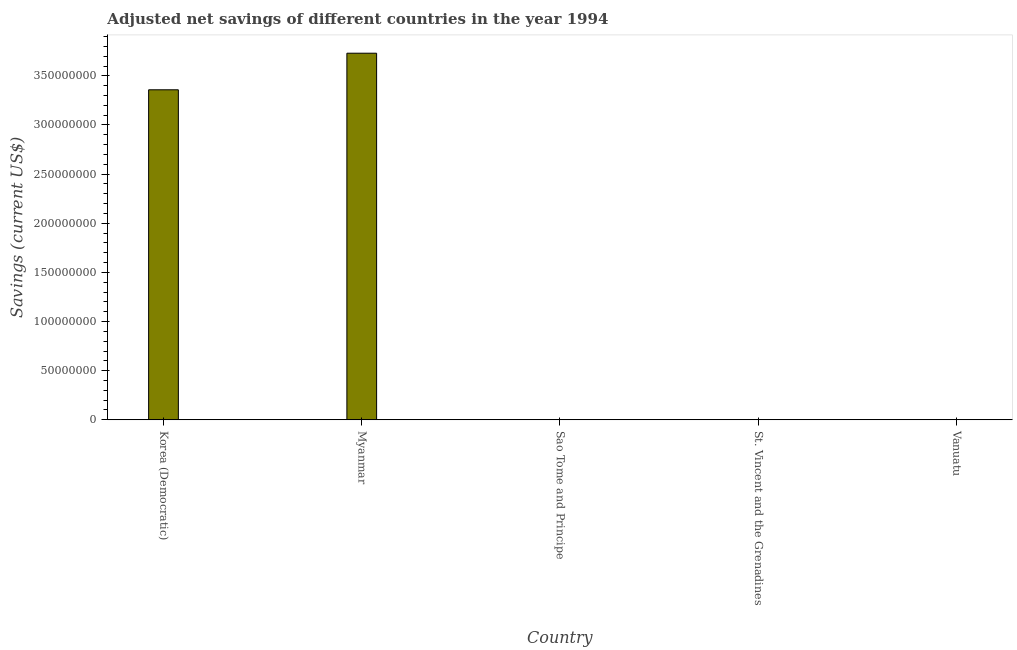Does the graph contain any zero values?
Offer a terse response. No. Does the graph contain grids?
Offer a very short reply. No. What is the title of the graph?
Offer a terse response. Adjusted net savings of different countries in the year 1994. What is the label or title of the Y-axis?
Keep it short and to the point. Savings (current US$). What is the adjusted net savings in St. Vincent and the Grenadines?
Your answer should be very brief. 8.75e+04. Across all countries, what is the maximum adjusted net savings?
Provide a succinct answer. 3.73e+08. Across all countries, what is the minimum adjusted net savings?
Provide a short and direct response. 5419.85. In which country was the adjusted net savings maximum?
Provide a succinct answer. Myanmar. In which country was the adjusted net savings minimum?
Your answer should be very brief. Sao Tome and Principe. What is the sum of the adjusted net savings?
Provide a short and direct response. 7.09e+08. What is the difference between the adjusted net savings in Myanmar and Sao Tome and Principe?
Offer a terse response. 3.73e+08. What is the average adjusted net savings per country?
Offer a terse response. 1.42e+08. What is the median adjusted net savings?
Make the answer very short. 2.82e+05. What is the ratio of the adjusted net savings in Sao Tome and Principe to that in St. Vincent and the Grenadines?
Provide a short and direct response. 0.06. What is the difference between the highest and the second highest adjusted net savings?
Your response must be concise. 3.72e+07. Is the sum of the adjusted net savings in Korea (Democratic) and St. Vincent and the Grenadines greater than the maximum adjusted net savings across all countries?
Ensure brevity in your answer.  No. What is the difference between the highest and the lowest adjusted net savings?
Keep it short and to the point. 3.73e+08. How many bars are there?
Your answer should be very brief. 5. What is the difference between two consecutive major ticks on the Y-axis?
Provide a succinct answer. 5.00e+07. What is the Savings (current US$) in Korea (Democratic)?
Your answer should be very brief. 3.36e+08. What is the Savings (current US$) of Myanmar?
Your response must be concise. 3.73e+08. What is the Savings (current US$) of Sao Tome and Principe?
Your response must be concise. 5419.85. What is the Savings (current US$) of St. Vincent and the Grenadines?
Your response must be concise. 8.75e+04. What is the Savings (current US$) in Vanuatu?
Your answer should be compact. 2.82e+05. What is the difference between the Savings (current US$) in Korea (Democratic) and Myanmar?
Make the answer very short. -3.72e+07. What is the difference between the Savings (current US$) in Korea (Democratic) and Sao Tome and Principe?
Provide a succinct answer. 3.36e+08. What is the difference between the Savings (current US$) in Korea (Democratic) and St. Vincent and the Grenadines?
Ensure brevity in your answer.  3.36e+08. What is the difference between the Savings (current US$) in Korea (Democratic) and Vanuatu?
Give a very brief answer. 3.36e+08. What is the difference between the Savings (current US$) in Myanmar and Sao Tome and Principe?
Provide a short and direct response. 3.73e+08. What is the difference between the Savings (current US$) in Myanmar and St. Vincent and the Grenadines?
Your answer should be compact. 3.73e+08. What is the difference between the Savings (current US$) in Myanmar and Vanuatu?
Provide a short and direct response. 3.73e+08. What is the difference between the Savings (current US$) in Sao Tome and Principe and St. Vincent and the Grenadines?
Keep it short and to the point. -8.20e+04. What is the difference between the Savings (current US$) in Sao Tome and Principe and Vanuatu?
Provide a short and direct response. -2.77e+05. What is the difference between the Savings (current US$) in St. Vincent and the Grenadines and Vanuatu?
Ensure brevity in your answer.  -1.95e+05. What is the ratio of the Savings (current US$) in Korea (Democratic) to that in Myanmar?
Your answer should be compact. 0.9. What is the ratio of the Savings (current US$) in Korea (Democratic) to that in Sao Tome and Principe?
Your answer should be very brief. 6.20e+04. What is the ratio of the Savings (current US$) in Korea (Democratic) to that in St. Vincent and the Grenadines?
Offer a very short reply. 3839.71. What is the ratio of the Savings (current US$) in Korea (Democratic) to that in Vanuatu?
Your answer should be compact. 1190.82. What is the ratio of the Savings (current US$) in Myanmar to that in Sao Tome and Principe?
Keep it short and to the point. 6.88e+04. What is the ratio of the Savings (current US$) in Myanmar to that in St. Vincent and the Grenadines?
Ensure brevity in your answer.  4265.41. What is the ratio of the Savings (current US$) in Myanmar to that in Vanuatu?
Your answer should be very brief. 1322.85. What is the ratio of the Savings (current US$) in Sao Tome and Principe to that in St. Vincent and the Grenadines?
Provide a short and direct response. 0.06. What is the ratio of the Savings (current US$) in Sao Tome and Principe to that in Vanuatu?
Give a very brief answer. 0.02. What is the ratio of the Savings (current US$) in St. Vincent and the Grenadines to that in Vanuatu?
Your answer should be compact. 0.31. 